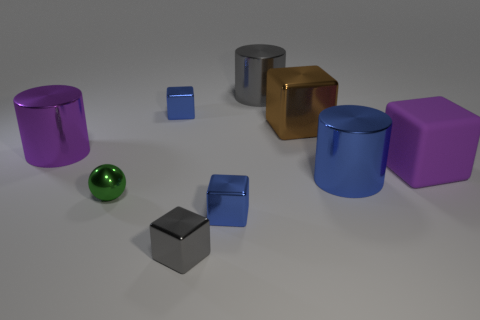Subtract all purple cubes. How many cubes are left? 4 Subtract 1 cubes. How many cubes are left? 4 Subtract all tiny gray metal cubes. How many cubes are left? 4 Subtract all red blocks. Subtract all green balls. How many blocks are left? 5 Add 1 large brown cubes. How many objects exist? 10 Subtract all cubes. How many objects are left? 4 Add 4 gray metal blocks. How many gray metal blocks exist? 5 Subtract 1 brown blocks. How many objects are left? 8 Subtract all large blue metallic cylinders. Subtract all purple matte blocks. How many objects are left? 7 Add 7 gray shiny cylinders. How many gray shiny cylinders are left? 8 